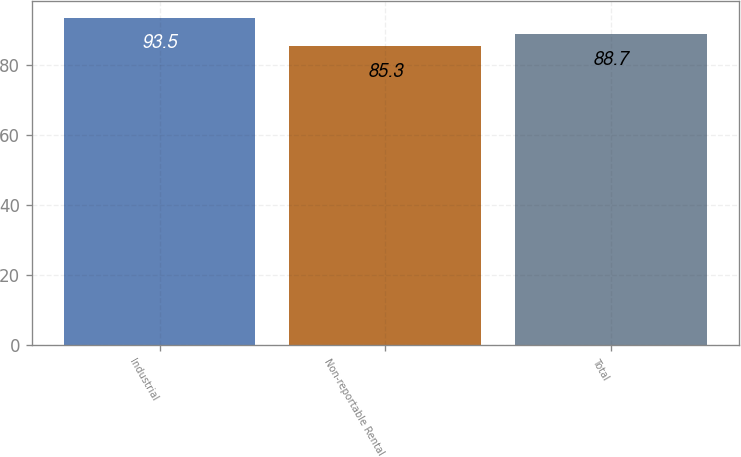Convert chart. <chart><loc_0><loc_0><loc_500><loc_500><bar_chart><fcel>Industrial<fcel>Non-reportable Rental<fcel>Total<nl><fcel>93.5<fcel>85.3<fcel>88.7<nl></chart> 